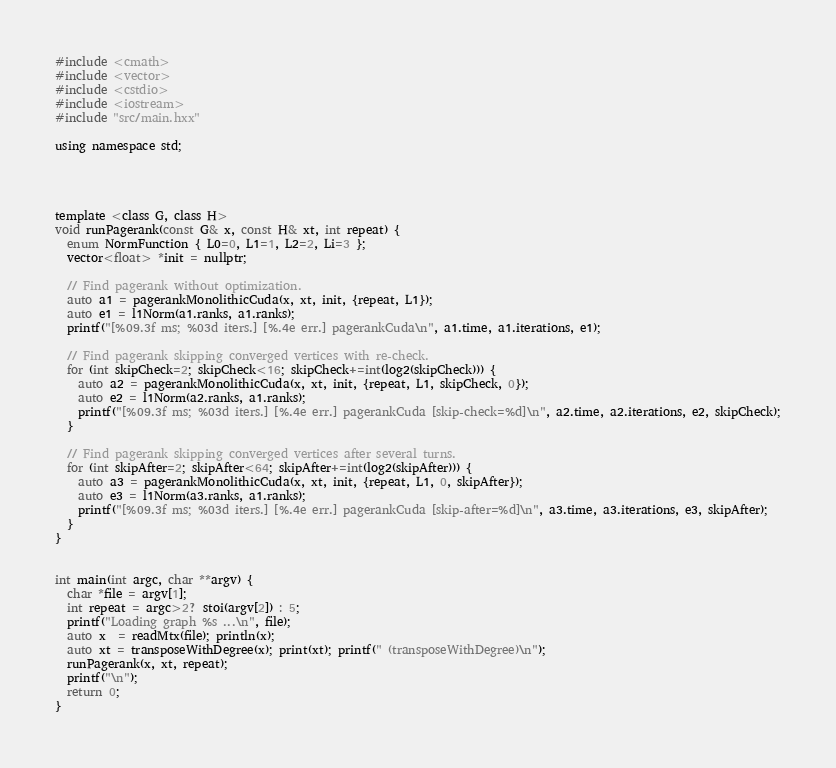<code> <loc_0><loc_0><loc_500><loc_500><_Cuda_>#include <cmath>
#include <vector>
#include <cstdio>
#include <iostream>
#include "src/main.hxx"

using namespace std;




template <class G, class H>
void runPagerank(const G& x, const H& xt, int repeat) {
  enum NormFunction { L0=0, L1=1, L2=2, Li=3 };
  vector<float> *init = nullptr;

  // Find pagerank without optimization.
  auto a1 = pagerankMonolithicCuda(x, xt, init, {repeat, L1});
  auto e1 = l1Norm(a1.ranks, a1.ranks);
  printf("[%09.3f ms; %03d iters.] [%.4e err.] pagerankCuda\n", a1.time, a1.iterations, e1);

  // Find pagerank skipping converged vertices with re-check.
  for (int skipCheck=2; skipCheck<16; skipCheck+=int(log2(skipCheck))) {
    auto a2 = pagerankMonolithicCuda(x, xt, init, {repeat, L1, skipCheck, 0});
    auto e2 = l1Norm(a2.ranks, a1.ranks);
    printf("[%09.3f ms; %03d iters.] [%.4e err.] pagerankCuda [skip-check=%d]\n", a2.time, a2.iterations, e2, skipCheck);
  }

  // Find pagerank skipping converged vertices after several turns.
  for (int skipAfter=2; skipAfter<64; skipAfter+=int(log2(skipAfter))) {
    auto a3 = pagerankMonolithicCuda(x, xt, init, {repeat, L1, 0, skipAfter});
    auto e3 = l1Norm(a3.ranks, a1.ranks);
    printf("[%09.3f ms; %03d iters.] [%.4e err.] pagerankCuda [skip-after=%d]\n", a3.time, a3.iterations, e3, skipAfter);
  }
}


int main(int argc, char **argv) {
  char *file = argv[1];
  int repeat = argc>2? stoi(argv[2]) : 5;
  printf("Loading graph %s ...\n", file);
  auto x  = readMtx(file); println(x);
  auto xt = transposeWithDegree(x); print(xt); printf(" (transposeWithDegree)\n");
  runPagerank(x, xt, repeat);
  printf("\n");
  return 0;
}
</code> 